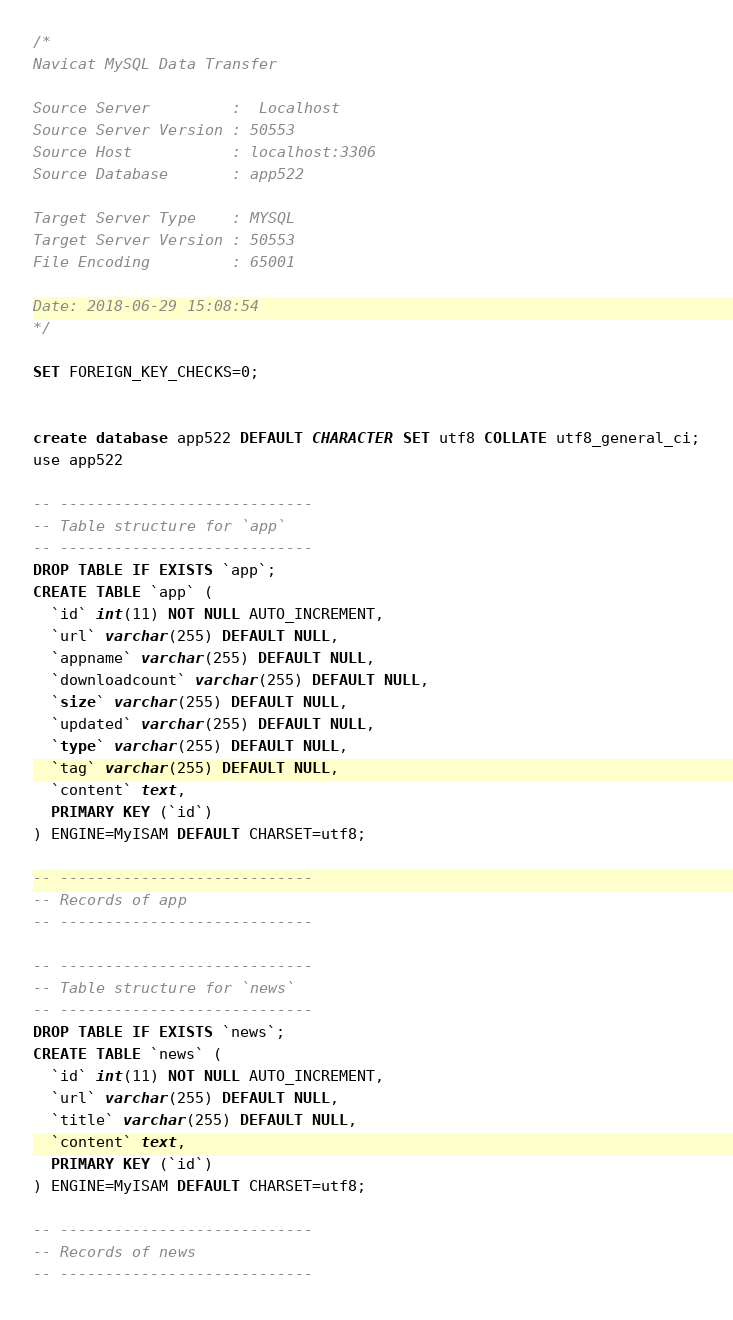Convert code to text. <code><loc_0><loc_0><loc_500><loc_500><_SQL_>/*
Navicat MySQL Data Transfer

Source Server         :  Localhost
Source Server Version : 50553
Source Host           : localhost:3306
Source Database       : app522

Target Server Type    : MYSQL
Target Server Version : 50553
File Encoding         : 65001

Date: 2018-06-29 15:08:54
*/

SET FOREIGN_KEY_CHECKS=0;


create database app522 DEFAULT CHARACTER SET utf8 COLLATE utf8_general_ci;
use app522

-- ----------------------------
-- Table structure for `app`
-- ----------------------------
DROP TABLE IF EXISTS `app`;
CREATE TABLE `app` (
  `id` int(11) NOT NULL AUTO_INCREMENT,
  `url` varchar(255) DEFAULT NULL,
  `appname` varchar(255) DEFAULT NULL,
  `downloadcount` varchar(255) DEFAULT NULL,
  `size` varchar(255) DEFAULT NULL,
  `updated` varchar(255) DEFAULT NULL,
  `type` varchar(255) DEFAULT NULL,
  `tag` varchar(255) DEFAULT NULL,
  `content` text,
  PRIMARY KEY (`id`)
) ENGINE=MyISAM DEFAULT CHARSET=utf8;

-- ----------------------------
-- Records of app
-- ----------------------------

-- ----------------------------
-- Table structure for `news`
-- ----------------------------
DROP TABLE IF EXISTS `news`;
CREATE TABLE `news` (
  `id` int(11) NOT NULL AUTO_INCREMENT,
  `url` varchar(255) DEFAULT NULL,
  `title` varchar(255) DEFAULT NULL,
  `content` text,
  PRIMARY KEY (`id`)
) ENGINE=MyISAM DEFAULT CHARSET=utf8;

-- ----------------------------
-- Records of news
-- ----------------------------
</code> 